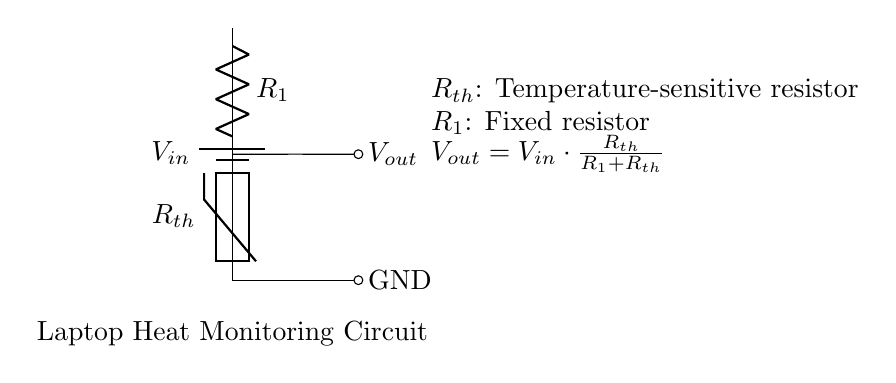What is the input voltage of the circuit? The input voltage is labeled as \( V_{in} \) in the circuit diagram. Since the specific value is not indicated, it refers to the supply voltage connected to the circuit.
Answer: \( V_{in} \) What type of resistor is \( R_{th} \)? \( R_{th} \) is labeled as a thermistor in the circuit diagram. A thermistor is a type of resistor whose resistance changes significantly with temperature.
Answer: thermistor What is the relationship of \( V_{out} \) in terms of \( V_{in} \), \( R_1 \), and \( R_{th} \)? The circuit provides the equation \( V_{out} = V_{in} \cdot \frac{R_{th}}{R_1 + R_{th}} \). This defines how the output voltage is calculated based on the input voltage and the resistances involved in the voltage divider setup.
Answer: \( V_{out} = V_{in} \cdot \frac{R_{th}}{R_1 + R_{th}} \) How does increasing the temperature affect \( R_{th} \)? As the temperature increases, typically, the resistance of a thermistor decreases. This means \( R_{th} \) will lower in value, affecting \( V_{out} \) based on the voltage divider equation provided in the circuit.
Answer: decreases What would happen to \( V_{out} \) if \( R_1 \) is increased? If \( R_1 \) is increased, by the equation \( V_{out} = V_{in} \cdot \frac{R_{th}}{R_1 + R_{th}} \), \( V_{out} \) will decrease because \( R_1 \) appears in the denominator, increasing the total resistance and reducing the output voltage.
Answer: decrease What is the function of this circuit? The circuit is designed to monitor the heat output of a laptop. The changing resistance in the thermistor \( R_{th} \) will provide information about the temperature, allowing for an output voltage that reflects the thermal conditions of the laptop.
Answer: monitor laptop heat 